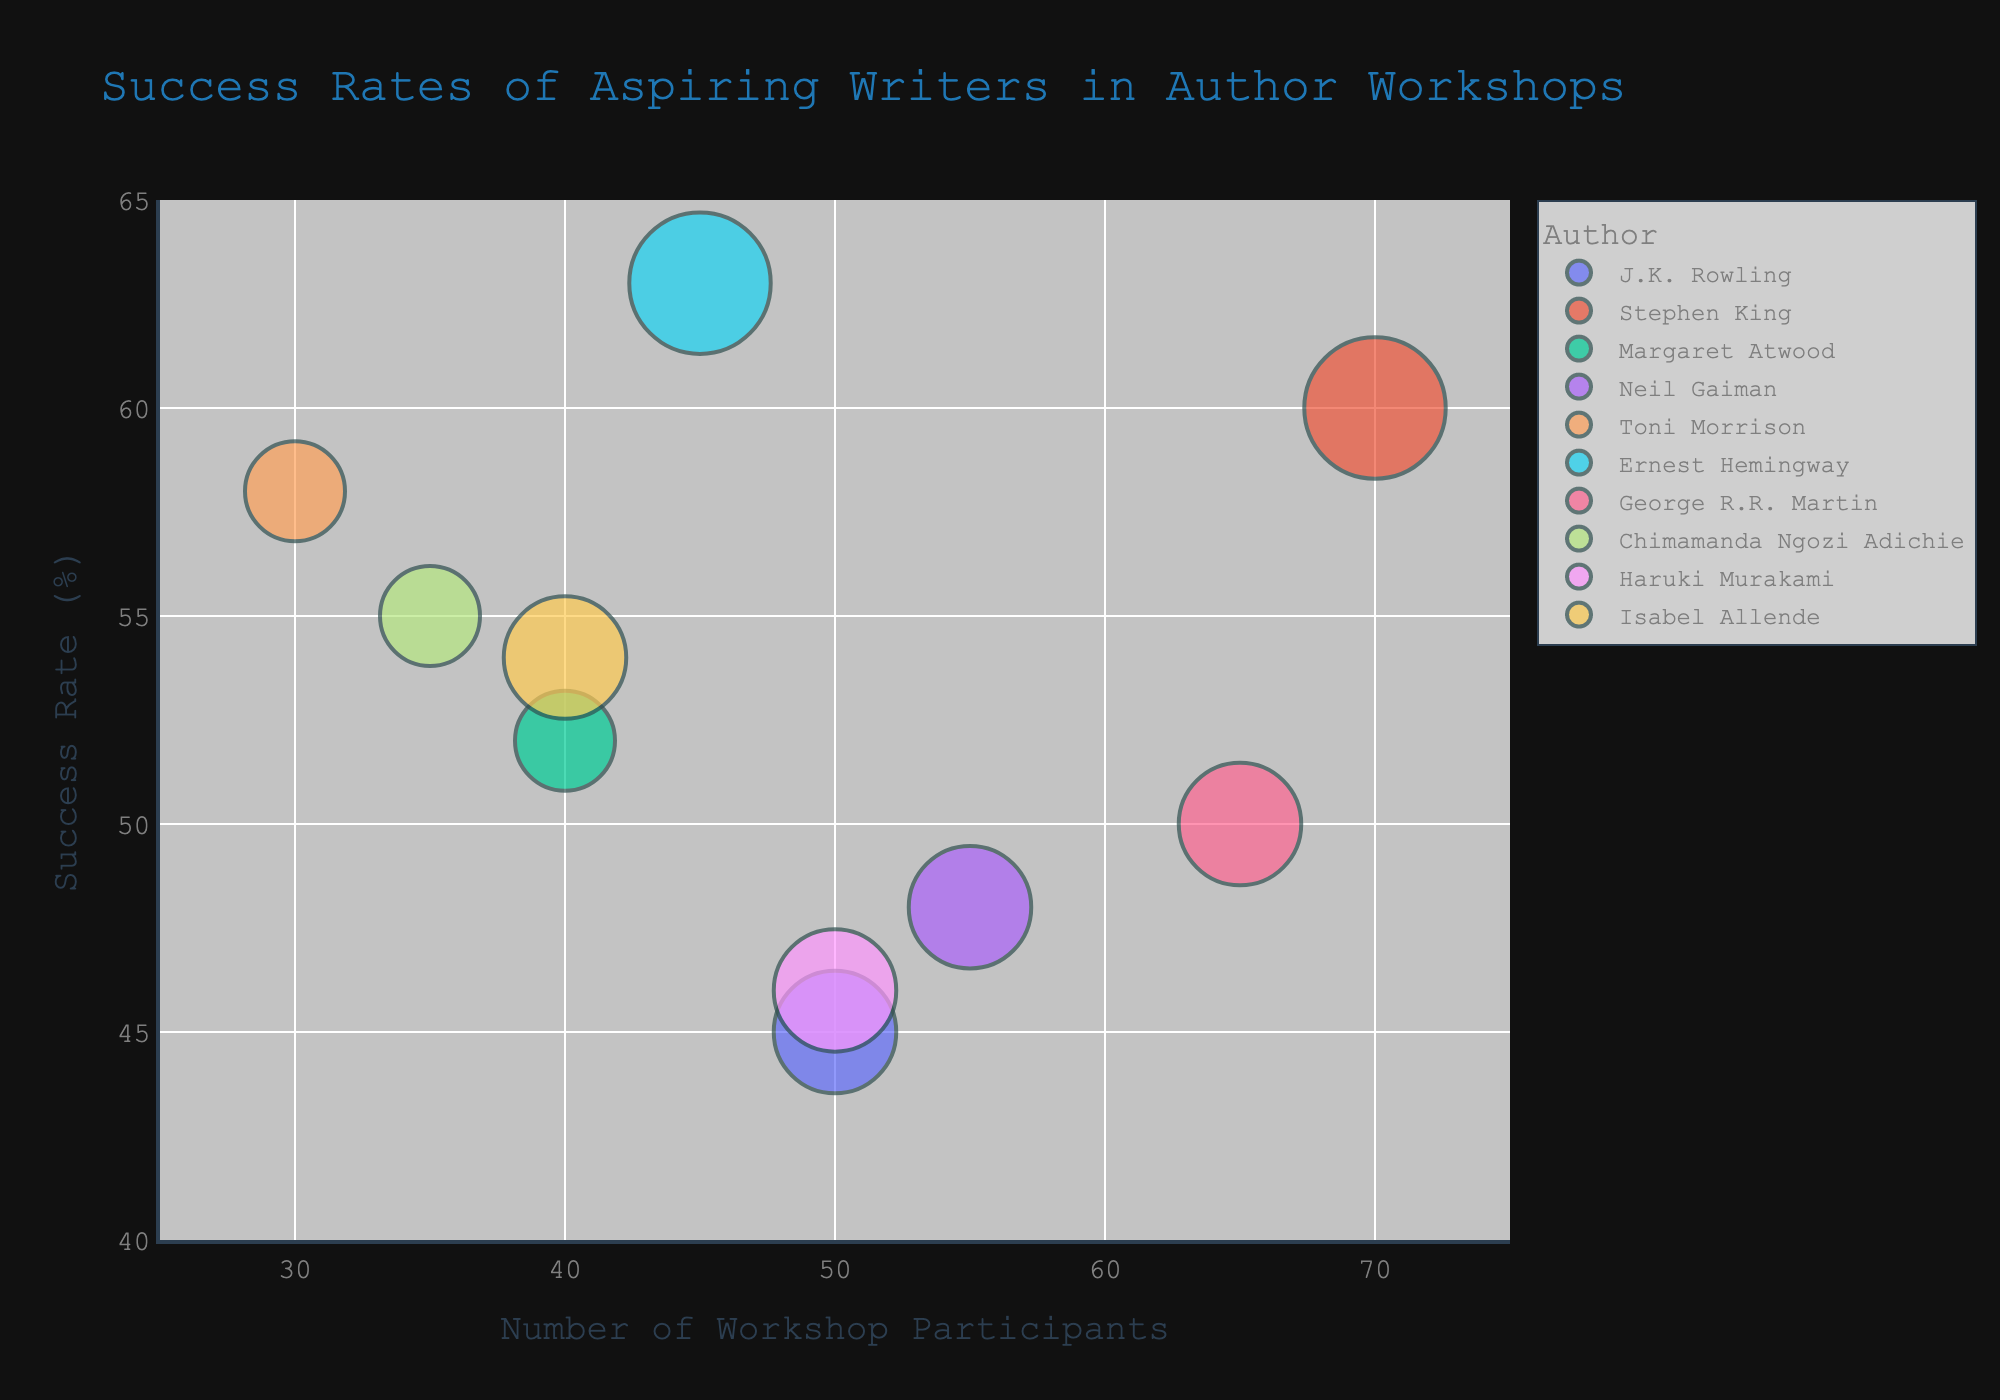What is the title of the chart? The title of the chart is displayed at the top of the figure.
Answer: Success Rates of Aspiring Writers in Author Workshops What are the axes labeled? The x-axis and y-axis labels are provided in the chart. The x-axis represents the number of workshop participants, and the y-axis represents the success rate in percentage.
Answer: Number of Workshop Participants, Success Rate (%) Which author has the highest success rate in workshops? By looking at the topmost point on the y-axis of the chart, we identify the corresponding author for that data point.
Answer: Ernest Hemingway How many workshop participants attended Stephen King's workshop? Locate the data point for Stephen King along the x-axis representing the number of workshop participants.
Answer: 70 How many publications on average do writers from Toni Morrison's workshop have? Check the bubble size for Toni Morrison, which indicates the average number of publications.
Answer: 2 Which author has the largest bubble size, and what does that signify? The author with the largest bubble size can be identified visually, and this size represents the average number of publications per writer.
Answer: Stephen King, 4 Is there an author whose workshop had fewer than 40 participants but achieved a success rate above 50%? Look at the data points where the x-axis value (participants) is below 40 and the y-axis value (success rate) is above 50%.
Answer: Toni Morrison, Chimamanda Ngozi Adichie Compare the success rates of workshops by J.K. Rowling and George R.R. Martin. Identify the y-axis values for both authors and compare them.
Answer: J.K. Rowling: 45%, George R.R. Martin: 50% Which authors have an average publication number of 3? Observe the bubble sizes to identify the authors with the corresponding size indicating an average publication of 3.
Answer: J.K. Rowling, Neil Gaiman, George R.R. Martin, Haruki Murakami, Isabel Allende What is the success rate difference between the workshops of Chimamanda Ngozi Adichie and Margaret Atwood? Identify the y-axis values for both authors and calculate the difference. Chimamanda's success rate is 55%, and Margaret's success rate is 52%. The difference is 55% - 52%.
Answer: 3% 